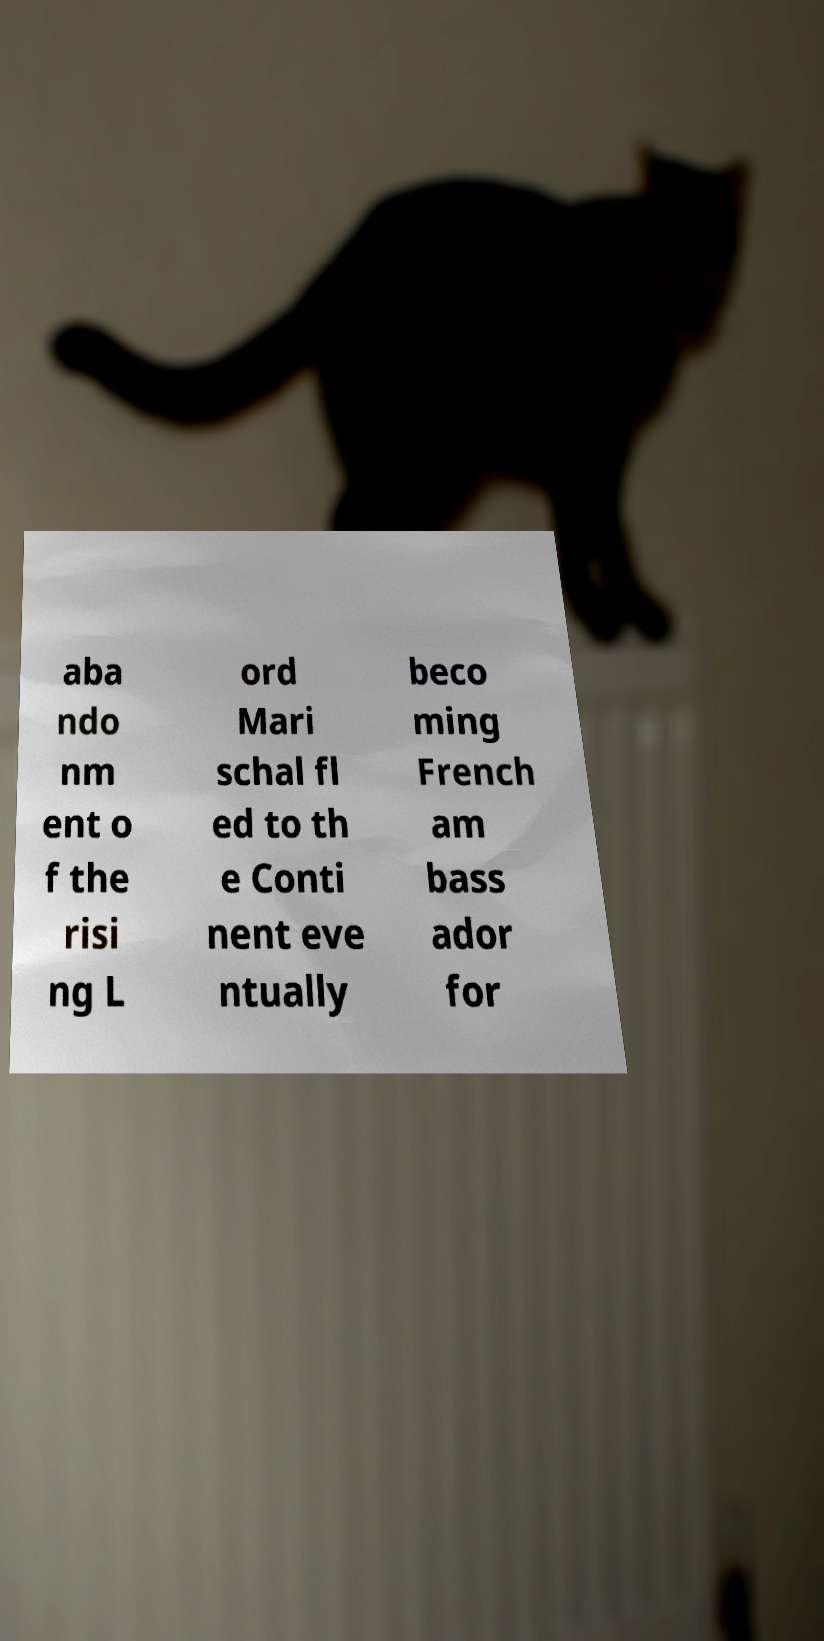Could you assist in decoding the text presented in this image and type it out clearly? aba ndo nm ent o f the risi ng L ord Mari schal fl ed to th e Conti nent eve ntually beco ming French am bass ador for 